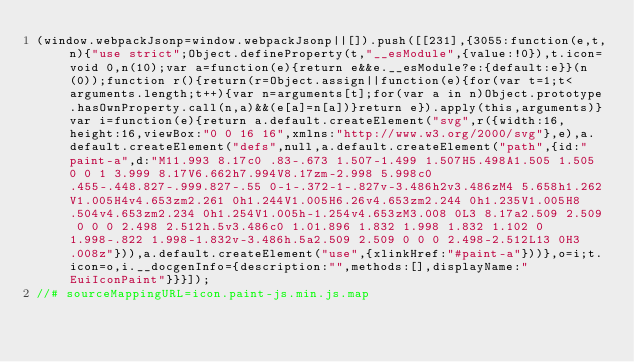Convert code to text. <code><loc_0><loc_0><loc_500><loc_500><_JavaScript_>(window.webpackJsonp=window.webpackJsonp||[]).push([[231],{3055:function(e,t,n){"use strict";Object.defineProperty(t,"__esModule",{value:!0}),t.icon=void 0,n(10);var a=function(e){return e&&e.__esModule?e:{default:e}}(n(0));function r(){return(r=Object.assign||function(e){for(var t=1;t<arguments.length;t++){var n=arguments[t];for(var a in n)Object.prototype.hasOwnProperty.call(n,a)&&(e[a]=n[a])}return e}).apply(this,arguments)}var i=function(e){return a.default.createElement("svg",r({width:16,height:16,viewBox:"0 0 16 16",xmlns:"http://www.w3.org/2000/svg"},e),a.default.createElement("defs",null,a.default.createElement("path",{id:"paint-a",d:"M11.993 8.17c0 .83-.673 1.507-1.499 1.507H5.498A1.505 1.505 0 0 1 3.999 8.17V6.662h7.994V8.17zm-2.998 5.998c0 .455-.448.827-.999.827-.55 0-1-.372-1-.827v-3.486h2v3.486zM4 5.658h1.262V1.005H4v4.653zm2.261 0h1.244V1.005H6.26v4.653zm2.244 0h1.235V1.005H8.504v4.653zm2.234 0h1.254V1.005h-1.254v4.653zM3.008 0L3 8.17a2.509 2.509 0 0 0 2.498 2.512h.5v3.486c0 1.01.896 1.832 1.998 1.832 1.102 0 1.998-.822 1.998-1.832v-3.486h.5a2.509 2.509 0 0 0 2.498-2.512L13 0H3.008z"})),a.default.createElement("use",{xlinkHref:"#paint-a"}))},o=i;t.icon=o,i.__docgenInfo={description:"",methods:[],displayName:"EuiIconPaint"}}}]);
//# sourceMappingURL=icon.paint-js.min.js.map</code> 